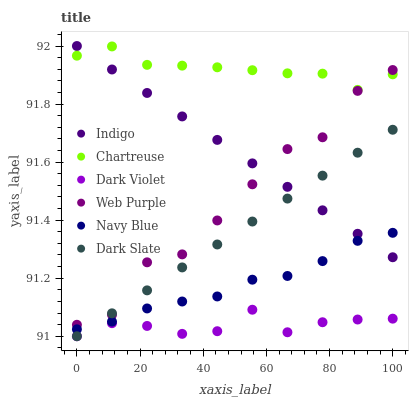Does Dark Violet have the minimum area under the curve?
Answer yes or no. Yes. Does Chartreuse have the maximum area under the curve?
Answer yes or no. Yes. Does Navy Blue have the minimum area under the curve?
Answer yes or no. No. Does Navy Blue have the maximum area under the curve?
Answer yes or no. No. Is Indigo the smoothest?
Answer yes or no. Yes. Is Web Purple the roughest?
Answer yes or no. Yes. Is Navy Blue the smoothest?
Answer yes or no. No. Is Navy Blue the roughest?
Answer yes or no. No. Does Dark Violet have the lowest value?
Answer yes or no. Yes. Does Navy Blue have the lowest value?
Answer yes or no. No. Does Indigo have the highest value?
Answer yes or no. Yes. Does Navy Blue have the highest value?
Answer yes or no. No. Is Dark Slate less than Chartreuse?
Answer yes or no. Yes. Is Chartreuse greater than Dark Slate?
Answer yes or no. Yes. Does Indigo intersect Web Purple?
Answer yes or no. Yes. Is Indigo less than Web Purple?
Answer yes or no. No. Is Indigo greater than Web Purple?
Answer yes or no. No. Does Dark Slate intersect Chartreuse?
Answer yes or no. No. 